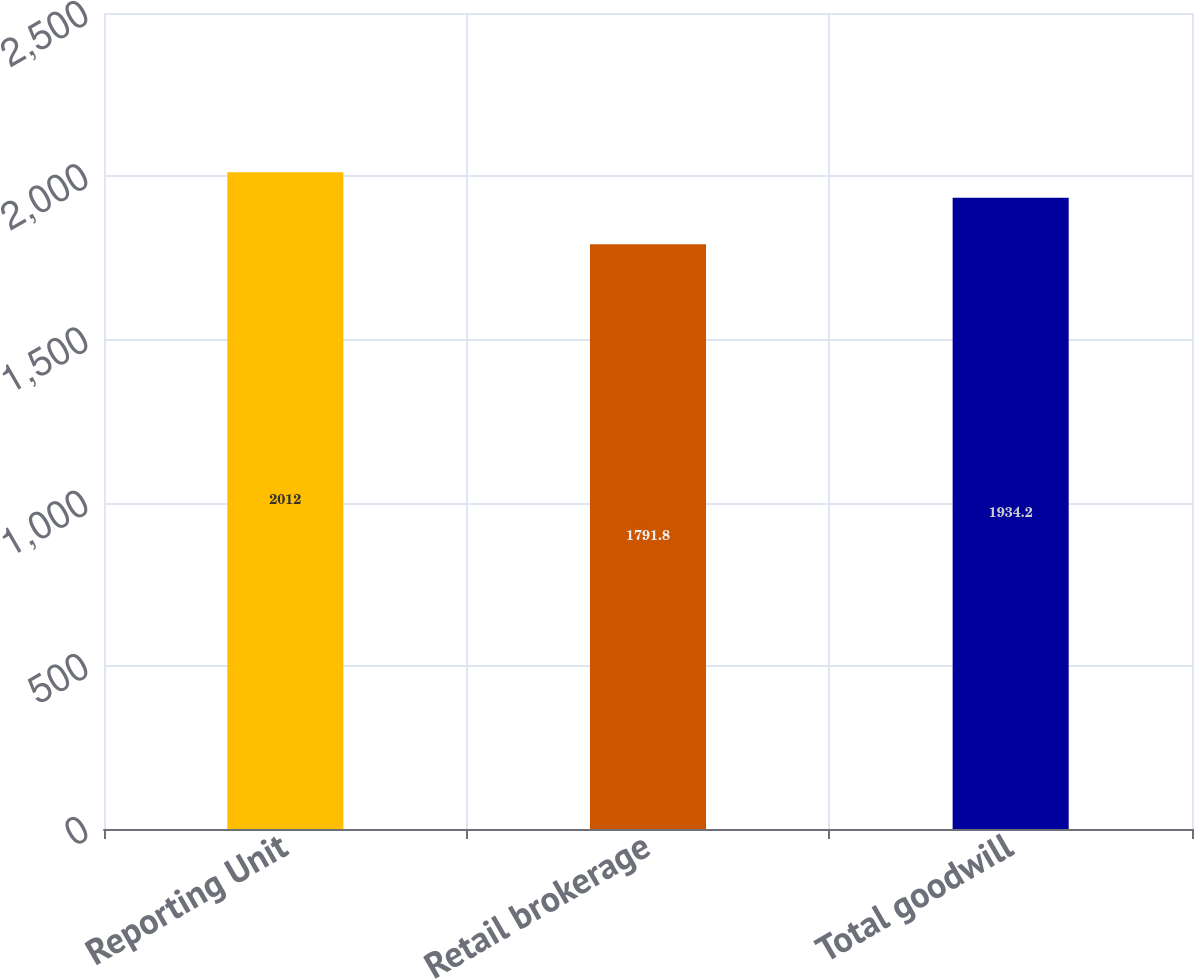Convert chart to OTSL. <chart><loc_0><loc_0><loc_500><loc_500><bar_chart><fcel>Reporting Unit<fcel>Retail brokerage<fcel>Total goodwill<nl><fcel>2012<fcel>1791.8<fcel>1934.2<nl></chart> 